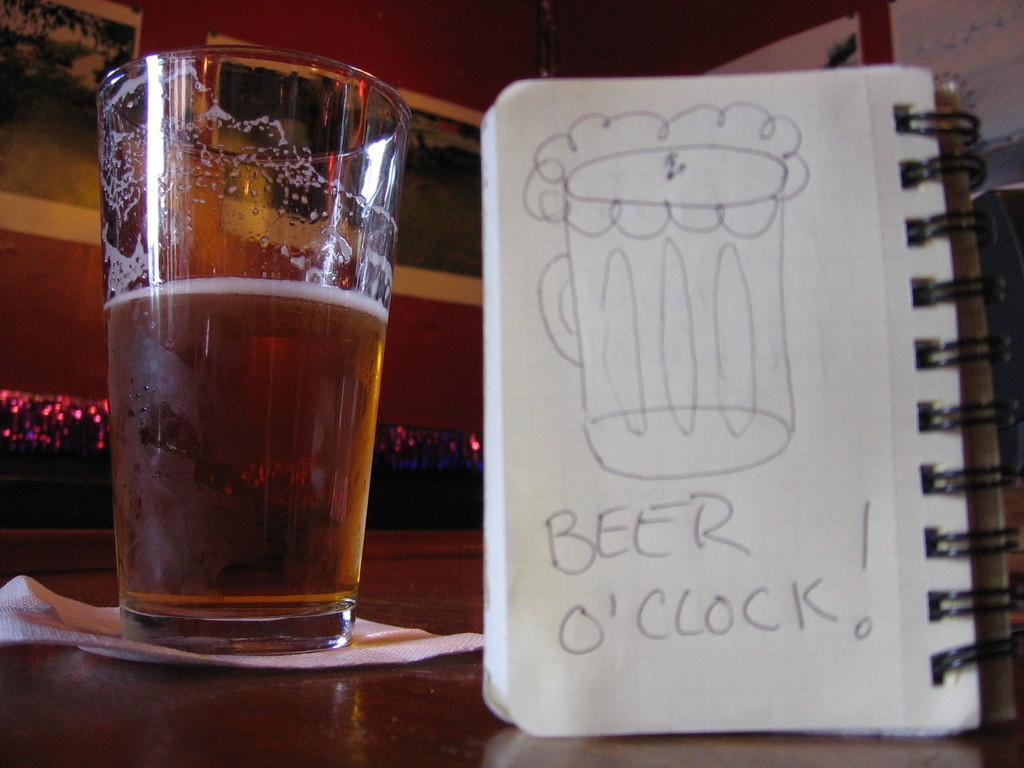<image>
Provide a brief description of the given image. A doodle of a frothy mug saying Beer O'Clock sits next to a real glass of brew. 